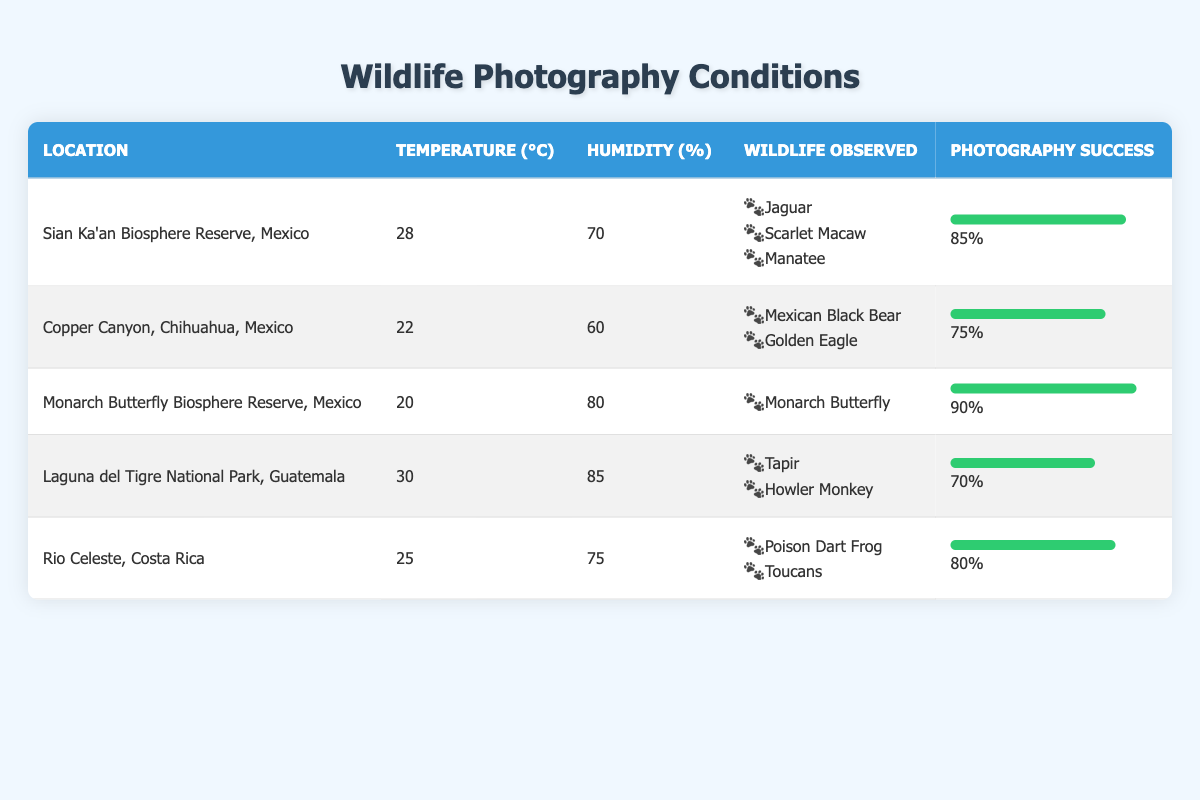What is the photography success percentage at the Monarch Butterfly Biosphere Reserve, Mexico? The table directly states that the photography success percentage for the Monarch Butterfly Biosphere Reserve is 90%.
Answer: 90% Which location has the highest photography success? By comparing the photography success values for all locations, the Monarch Butterfly Biosphere Reserve has the highest success percentage at 90%.
Answer: Monarch Butterfly Biosphere Reserve, Mexico How many wildlife species were observed in Sian Ka'an Biosphere Reserve, Mexico? The table lists three species observed in Sian Ka'an: Jaguar, Scarlet Macaw, and Manatee, thus there are 3 species in total.
Answer: 3 What is the average temperature of the locations listed? To find the average temperature, we sum the temperatures (28 + 22 + 20 + 30 + 25 = 125) and divide by the number of locations (5), resulting in an average temperature of 25 degrees Celsius.
Answer: 25 Is the humidity level at Copper Canyon, Chihuahua higher than 65%? The humidity level at Copper Canyon is listed as 60%, which is lower than 65%. Thus, the answer is no.
Answer: No What is the difference in photography success between Sian Ka'an Biosphere Reserve and Laguna del Tigre National Park? Sian Ka'an has a photography success of 85% while Laguna del Tigre has a success of 70%. The difference is 85% - 70% = 15%.
Answer: 15% Do any of these locations observe the Jaguar? Sian Ka'an Biosphere Reserve is the only location that lists the Jaguar among the wildlife observed.
Answer: Yes Which location has the lowest humidity level? The table indicates that Copper Canyon has the lowest humidity level at 60%.
Answer: Copper Canyon, Chihuahua, Mexico What is the relationship between temperature and photography success in the table? As we inspect the data, we see varied temperature and photography success values, but Monarch Butterfly Biosphere Reserve has both a low temperature (20°C) and high success (90%). This suggests that lower temperatures may still yield high photography success in some conditions.
Answer: Varied; not directly correlated, but lower temp can be successful 